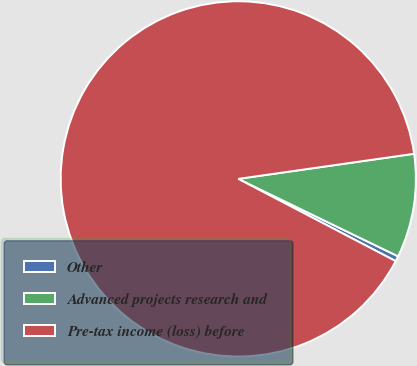Convert chart. <chart><loc_0><loc_0><loc_500><loc_500><pie_chart><fcel>Other<fcel>Advanced projects research and<fcel>Pre-tax income (loss) before<nl><fcel>0.48%<fcel>9.44%<fcel>90.07%<nl></chart> 